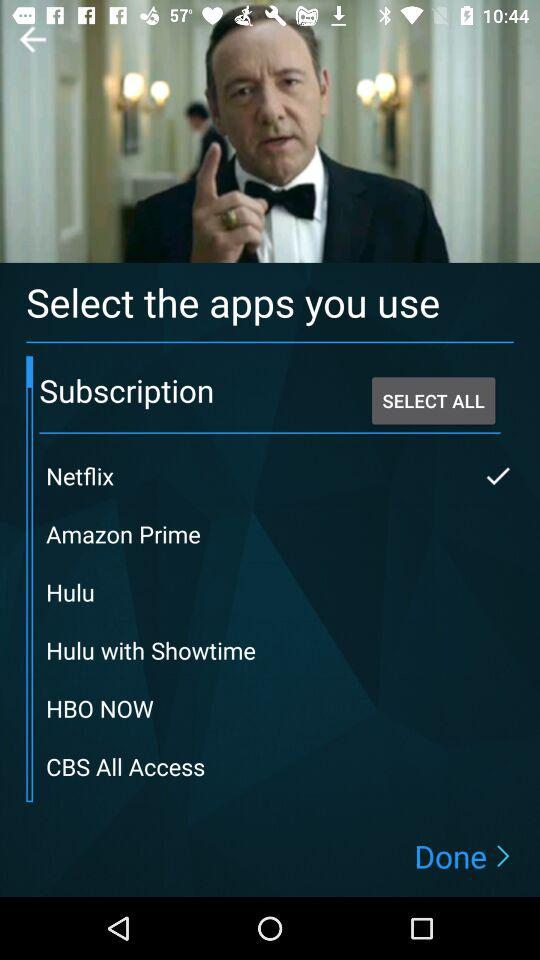How many services are available to subscribe to?
Answer the question using a single word or phrase. 6 